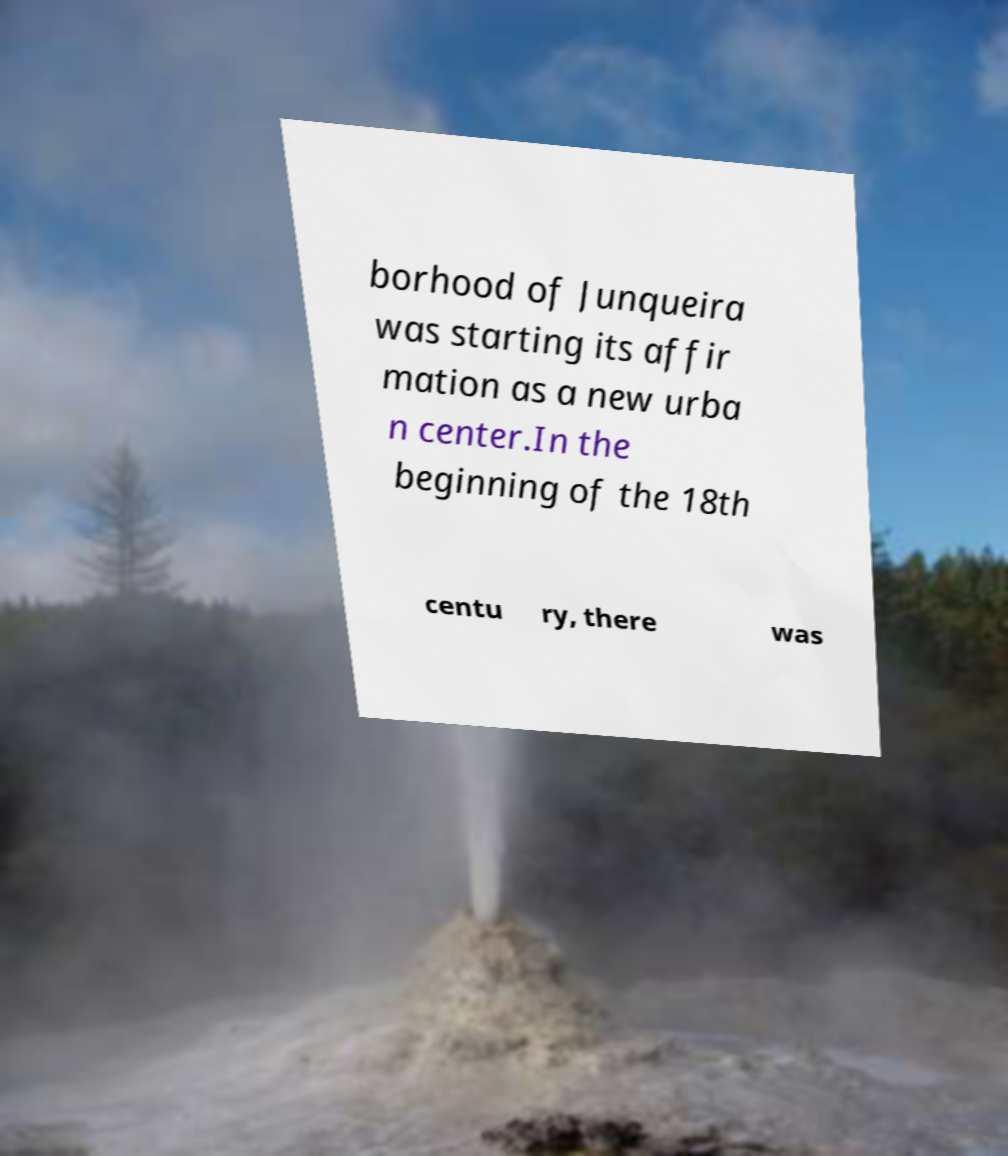Could you extract and type out the text from this image? borhood of Junqueira was starting its affir mation as a new urba n center.In the beginning of the 18th centu ry, there was 